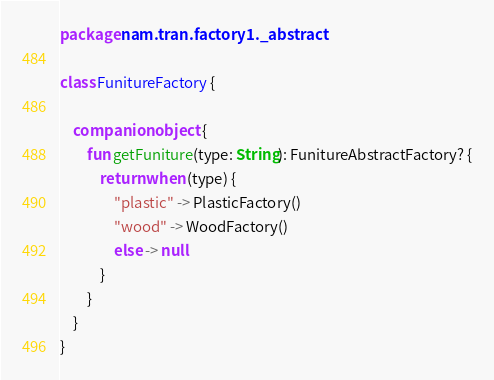<code> <loc_0><loc_0><loc_500><loc_500><_Kotlin_>package nam.tran.factory1._abstract

class FunitureFactory {

    companion object {
        fun getFuniture(type: String): FunitureAbstractFactory? {
            return when (type) {
                "plastic" -> PlasticFactory()
                "wood" -> WoodFactory()
                else -> null
            }
        }
    }
}</code> 